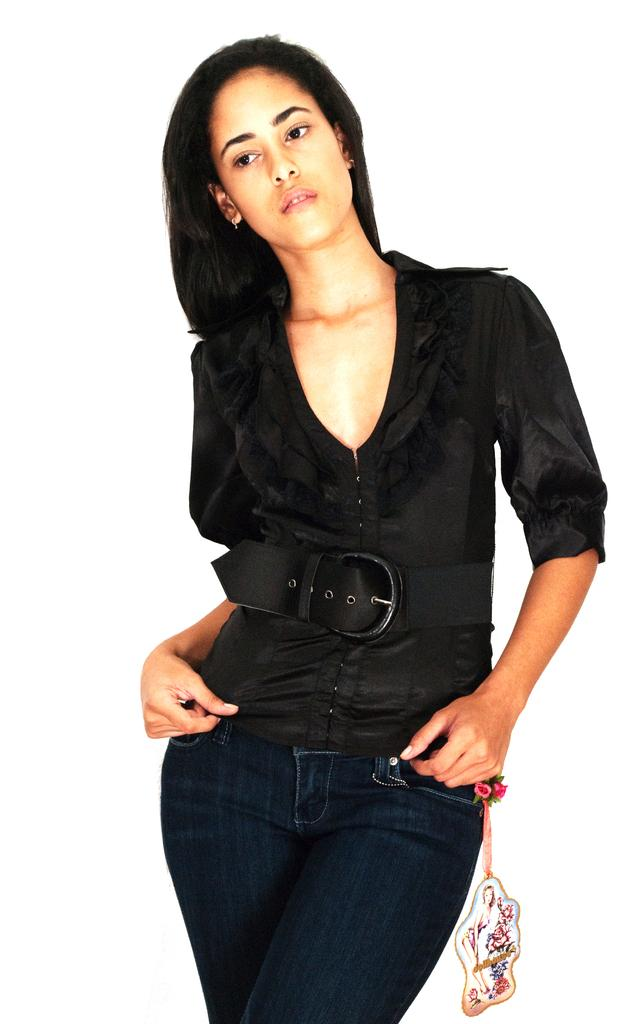Who is the main subject in the foreground of the image? There is a woman in the foreground of the image. What is the woman doing in the image? The woman is standing. What color is the shirt the woman is wearing? The woman is wearing a black shirt. Can you describe any additional details about the woman's clothing? There is a tag tied to the jeans the woman is wearing. What is the color of the background in the image? The background of the image is white. What type of prison can be seen in the background of the image? There is no prison present in the image; the background is white. What kind of disease is the woman suffering from in the image? There is no indication of any disease in the image; the woman is simply standing and wearing a black shirt with a tag on her jeans. 